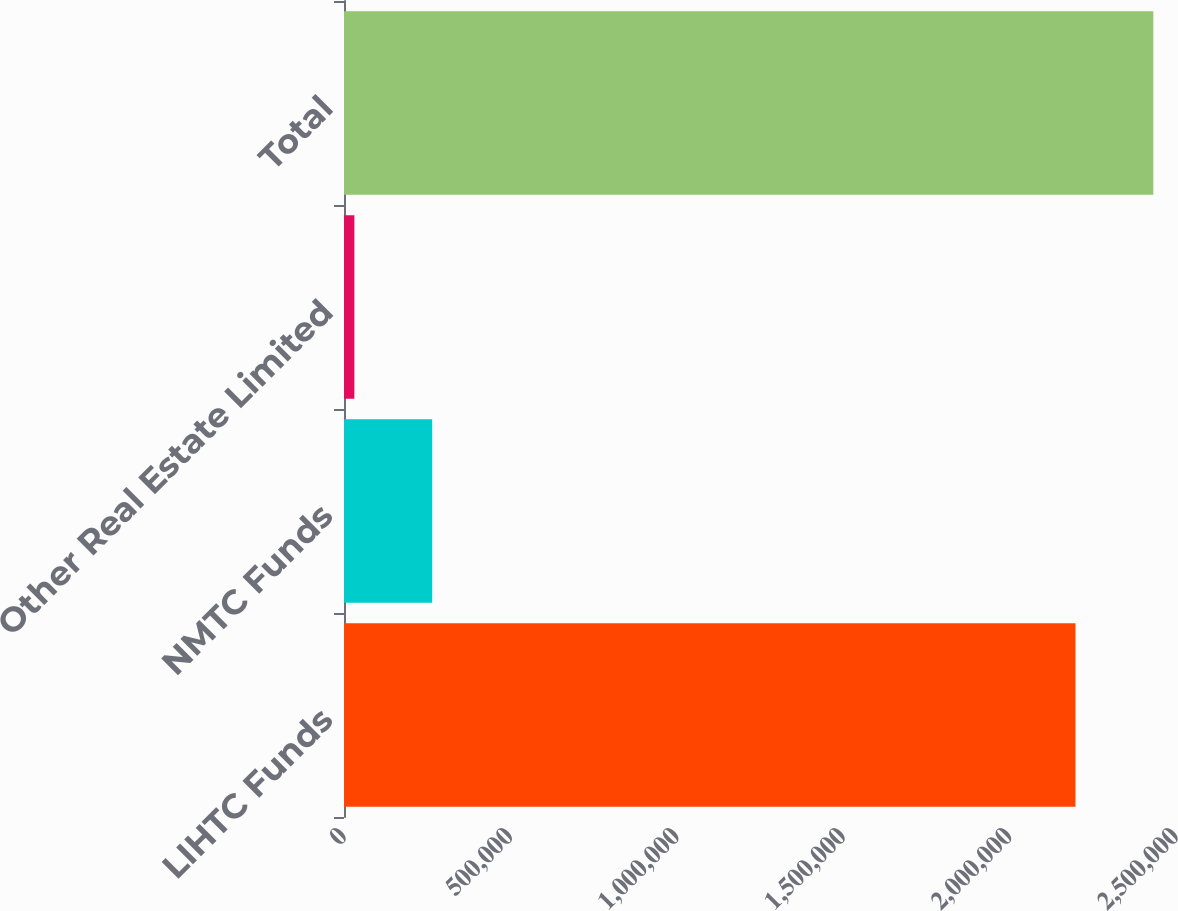Convert chart. <chart><loc_0><loc_0><loc_500><loc_500><bar_chart><fcel>LIHTC Funds<fcel>NMTC Funds<fcel>Other Real Estate Limited<fcel>Total<nl><fcel>2.19805e+06<fcel>264980<fcel>31107<fcel>2.43192e+06<nl></chart> 